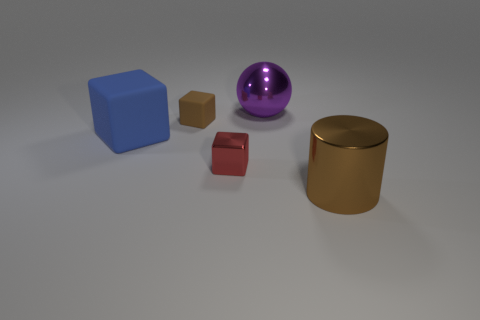What is the color of the other big object that is the same shape as the brown matte object?
Your answer should be very brief. Blue. What number of matte things are either large blue blocks or red blocks?
Your answer should be very brief. 1. There is a big metal object that is behind the thing on the right side of the big purple ball; are there any large brown shiny objects behind it?
Your response must be concise. No. The small metallic thing is what color?
Make the answer very short. Red. Does the big metallic object that is left of the large brown object have the same shape as the small brown thing?
Keep it short and to the point. No. How many objects are either brown cubes or brown things that are behind the brown cylinder?
Provide a short and direct response. 1. Is the brown object behind the large metallic cylinder made of the same material as the large blue cube?
Provide a short and direct response. Yes. The small block in front of the rubber thing that is behind the large blue rubber thing is made of what material?
Your answer should be very brief. Metal. Are there more large brown shiny cylinders that are to the right of the blue thing than big brown cylinders on the left side of the tiny red object?
Keep it short and to the point. Yes. What size is the red thing?
Offer a terse response. Small. 